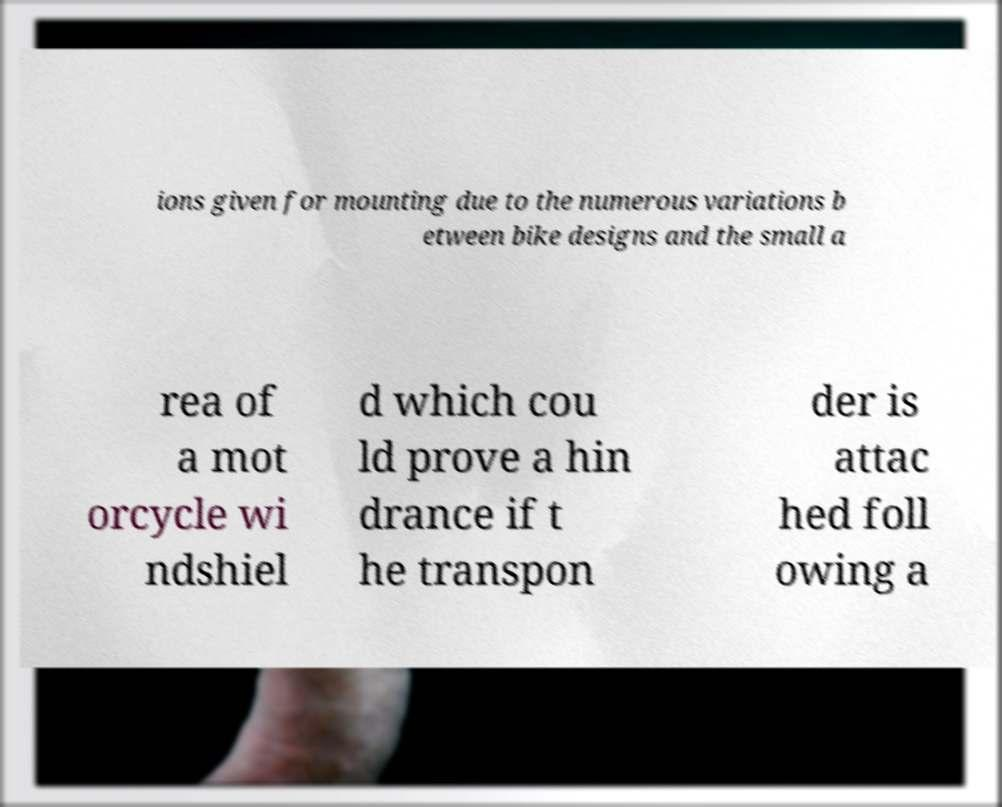I need the written content from this picture converted into text. Can you do that? ions given for mounting due to the numerous variations b etween bike designs and the small a rea of a mot orcycle wi ndshiel d which cou ld prove a hin drance if t he transpon der is attac hed foll owing a 